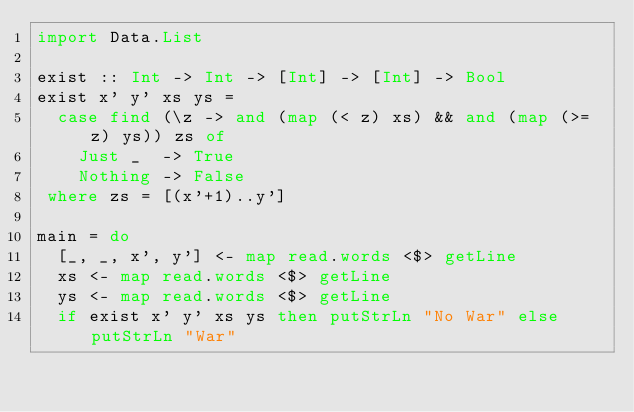Convert code to text. <code><loc_0><loc_0><loc_500><loc_500><_Haskell_>import Data.List

exist :: Int -> Int -> [Int] -> [Int] -> Bool
exist x' y' xs ys =
  case find (\z -> and (map (< z) xs) && and (map (>= z) ys)) zs of
    Just _  -> True
    Nothing -> False
 where zs = [(x'+1)..y']

main = do
  [_, _, x', y'] <- map read.words <$> getLine
  xs <- map read.words <$> getLine
  ys <- map read.words <$> getLine
  if exist x' y' xs ys then putStrLn "No War" else putStrLn "War"
</code> 